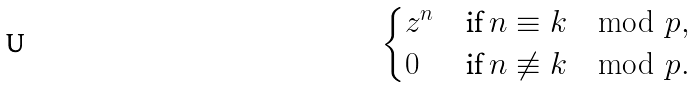<formula> <loc_0><loc_0><loc_500><loc_500>\begin{cases} z ^ { n } & \text {if } n \equiv k \mod { p } , \\ 0 & \text {if } n \not \equiv k \mod { p } . \end{cases}</formula> 